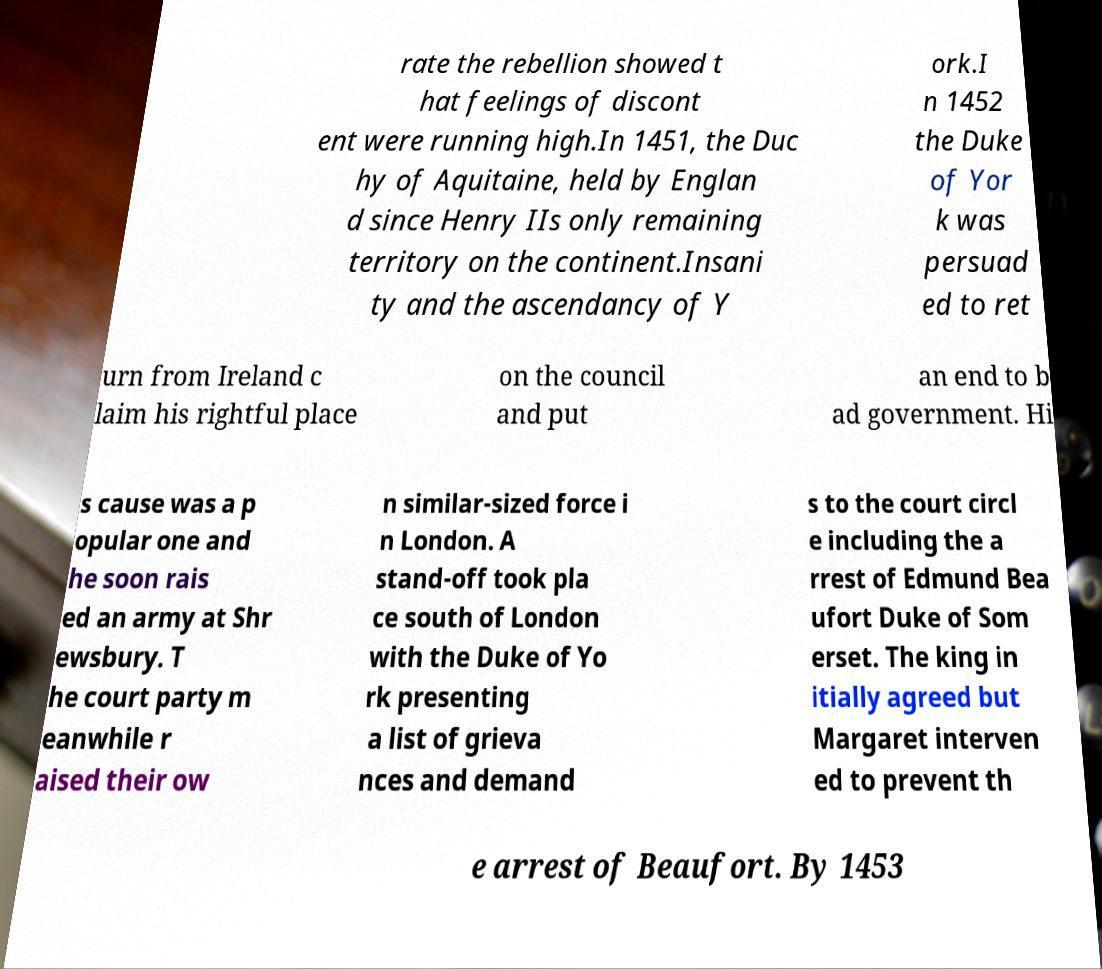For documentation purposes, I need the text within this image transcribed. Could you provide that? rate the rebellion showed t hat feelings of discont ent were running high.In 1451, the Duc hy of Aquitaine, held by Englan d since Henry IIs only remaining territory on the continent.Insani ty and the ascendancy of Y ork.I n 1452 the Duke of Yor k was persuad ed to ret urn from Ireland c laim his rightful place on the council and put an end to b ad government. Hi s cause was a p opular one and he soon rais ed an army at Shr ewsbury. T he court party m eanwhile r aised their ow n similar-sized force i n London. A stand-off took pla ce south of London with the Duke of Yo rk presenting a list of grieva nces and demand s to the court circl e including the a rrest of Edmund Bea ufort Duke of Som erset. The king in itially agreed but Margaret interven ed to prevent th e arrest of Beaufort. By 1453 